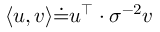Convert formula to latex. <formula><loc_0><loc_0><loc_500><loc_500>{ \langle u , v \rangle \dot { = } u ^ { \top } \cdot \sigma ^ { - 2 } v }</formula> 